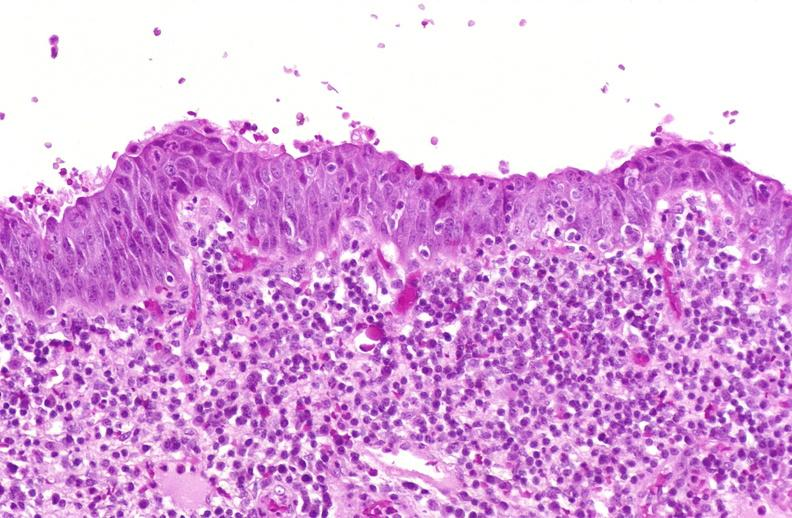what does this image show?
Answer the question using a single word or phrase. Squamous metaplasia 